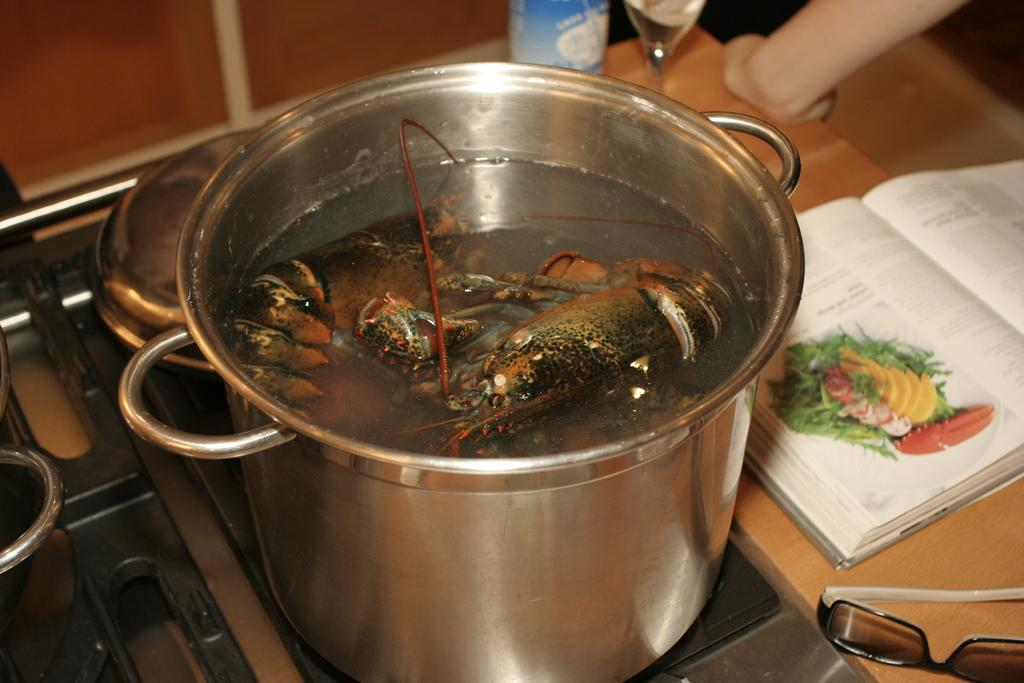What type of bowl is in the image? There is a steel bowl in the image. What is inside the bowl? There are objects in brown color in the bowl. What can be seen in the background of the image? There is a book and a glass in the background of the image. What is the color of the table in the image? The table is in brown color. How does the umbrella help to increase the value of the image? There is no umbrella present in the image, so it cannot be used to increase the value of the image. 